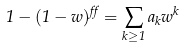<formula> <loc_0><loc_0><loc_500><loc_500>1 - ( 1 - w ) ^ { \alpha } = \sum _ { k \geq 1 } a _ { k } w ^ { k }</formula> 